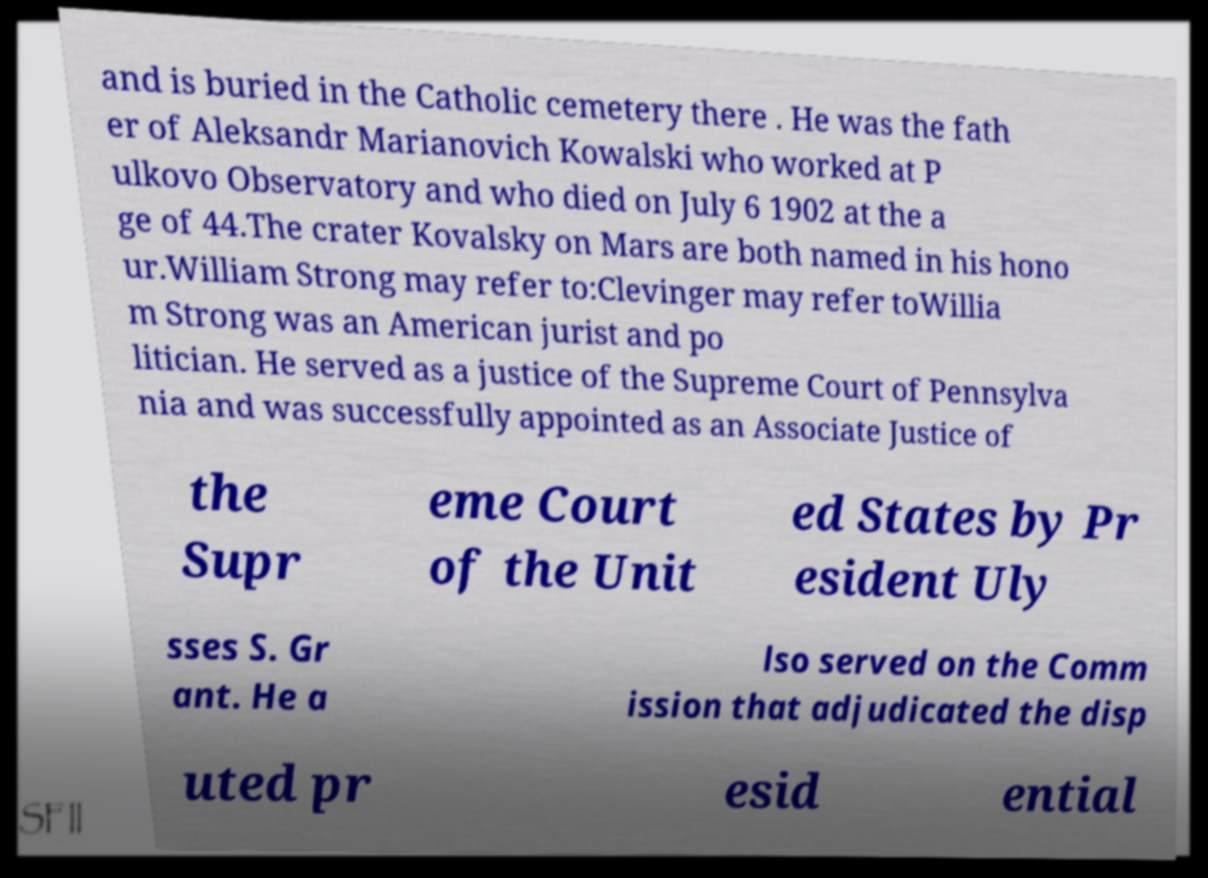Please read and relay the text visible in this image. What does it say? and is buried in the Catholic cemetery there . He was the fath er of Aleksandr Marianovich Kowalski who worked at P ulkovo Observatory and who died on July 6 1902 at the a ge of 44.The crater Kovalsky on Mars are both named in his hono ur.William Strong may refer to:Clevinger may refer toWillia m Strong was an American jurist and po litician. He served as a justice of the Supreme Court of Pennsylva nia and was successfully appointed as an Associate Justice of the Supr eme Court of the Unit ed States by Pr esident Uly sses S. Gr ant. He a lso served on the Comm ission that adjudicated the disp uted pr esid ential 